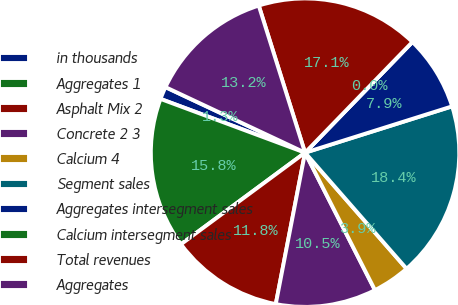Convert chart. <chart><loc_0><loc_0><loc_500><loc_500><pie_chart><fcel>in thousands<fcel>Aggregates 1<fcel>Asphalt Mix 2<fcel>Concrete 2 3<fcel>Calcium 4<fcel>Segment sales<fcel>Aggregates intersegment sales<fcel>Calcium intersegment sales<fcel>Total revenues<fcel>Aggregates<nl><fcel>1.32%<fcel>15.79%<fcel>11.84%<fcel>10.53%<fcel>3.95%<fcel>18.42%<fcel>7.89%<fcel>0.0%<fcel>17.11%<fcel>13.16%<nl></chart> 